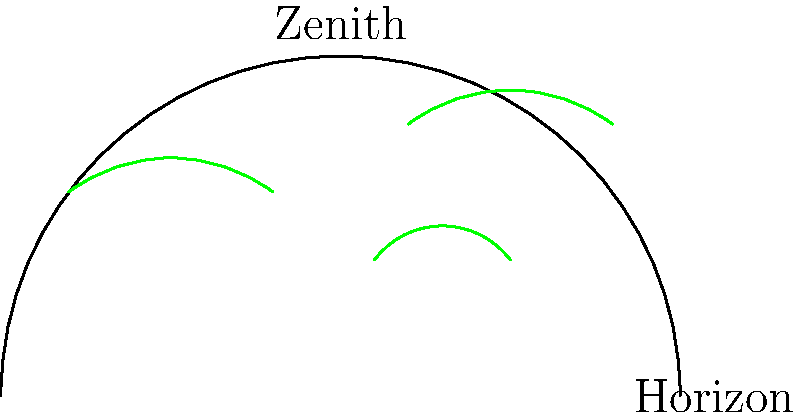In a hemispherical photograph used for calculating Leaf Area Index (LAI), what is the primary reason for dividing the hemisphere into concentric rings, and how does this division contribute to the accuracy of LAI estimation? To understand the importance of dividing a hemispherical photograph into concentric rings for LAI calculation, let's break down the process:

1. Hemispherical photography captures a 180° view of the canopy from below.

2. The photograph is divided into concentric rings for several reasons:

   a) To account for the zenith angle: As we move from the center (zenith) to the edge (horizon), the view angle changes.
   
   b) To apply gap fraction analysis: Each ring represents a different zenith angle range.

3. The primary reason for this division is to account for the changing contribution of foliage at different angles to the overall canopy cover.

4. Importance of the division:
   
   a) Leaves at the zenith (center of the image) contribute more to light interception than those near the horizon.
   
   b) The area of sky represented by each ring increases as you move from zenith to horizon.

5. LAI calculation process:
   
   a) For each ring, the ratio of sky to foliage is calculated (gap fraction).
   
   b) This gap fraction is weighted based on the ring's zenith angle.
   
   c) The weighted values are used in the LAI estimation equation:
      
      $$LAI = -\frac{\ln(P(\theta))}{G(\theta)} \cdot \frac{1}{\cos(\theta)}$$
      
      Where $P(\theta)$ is the gap fraction at zenith angle $\theta$, and $G(\theta)$ is the leaf angle distribution function.

6. The division into rings allows for more accurate integration of these weighted values across the entire hemisphere.

7. This method accounts for the fact that leaves at different angles contribute differently to light interception and thus to the LAI.

By dividing the hemisphere into concentric rings, we can more accurately account for the spatial distribution of foliage and its varying contribution to light interception, resulting in a more precise LAI estimation.
Answer: To account for varying foliage contribution at different zenith angles, improving LAI accuracy. 